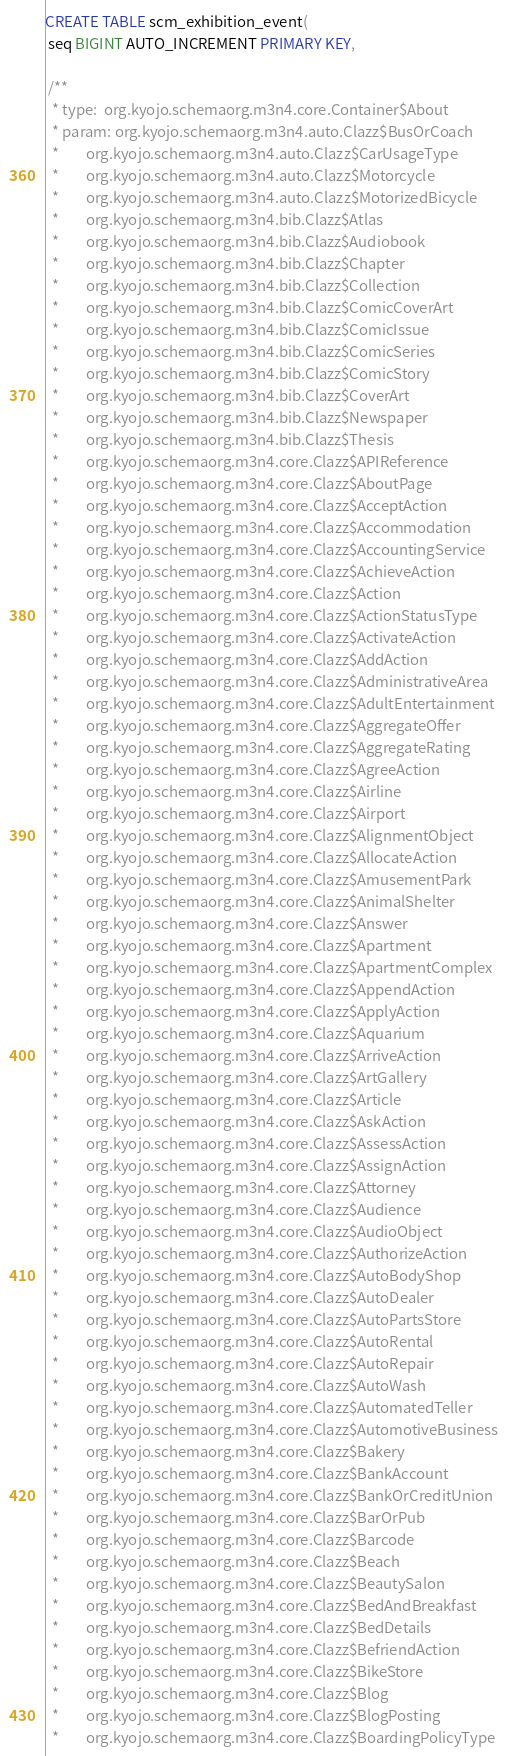<code> <loc_0><loc_0><loc_500><loc_500><_SQL_>CREATE TABLE scm_exhibition_event(
 seq BIGINT AUTO_INCREMENT PRIMARY KEY,

 /**
  * type:  org.kyojo.schemaorg.m3n4.core.Container$About
  * param: org.kyojo.schemaorg.m3n4.auto.Clazz$BusOrCoach
  *        org.kyojo.schemaorg.m3n4.auto.Clazz$CarUsageType
  *        org.kyojo.schemaorg.m3n4.auto.Clazz$Motorcycle
  *        org.kyojo.schemaorg.m3n4.auto.Clazz$MotorizedBicycle
  *        org.kyojo.schemaorg.m3n4.bib.Clazz$Atlas
  *        org.kyojo.schemaorg.m3n4.bib.Clazz$Audiobook
  *        org.kyojo.schemaorg.m3n4.bib.Clazz$Chapter
  *        org.kyojo.schemaorg.m3n4.bib.Clazz$Collection
  *        org.kyojo.schemaorg.m3n4.bib.Clazz$ComicCoverArt
  *        org.kyojo.schemaorg.m3n4.bib.Clazz$ComicIssue
  *        org.kyojo.schemaorg.m3n4.bib.Clazz$ComicSeries
  *        org.kyojo.schemaorg.m3n4.bib.Clazz$ComicStory
  *        org.kyojo.schemaorg.m3n4.bib.Clazz$CoverArt
  *        org.kyojo.schemaorg.m3n4.bib.Clazz$Newspaper
  *        org.kyojo.schemaorg.m3n4.bib.Clazz$Thesis
  *        org.kyojo.schemaorg.m3n4.core.Clazz$APIReference
  *        org.kyojo.schemaorg.m3n4.core.Clazz$AboutPage
  *        org.kyojo.schemaorg.m3n4.core.Clazz$AcceptAction
  *        org.kyojo.schemaorg.m3n4.core.Clazz$Accommodation
  *        org.kyojo.schemaorg.m3n4.core.Clazz$AccountingService
  *        org.kyojo.schemaorg.m3n4.core.Clazz$AchieveAction
  *        org.kyojo.schemaorg.m3n4.core.Clazz$Action
  *        org.kyojo.schemaorg.m3n4.core.Clazz$ActionStatusType
  *        org.kyojo.schemaorg.m3n4.core.Clazz$ActivateAction
  *        org.kyojo.schemaorg.m3n4.core.Clazz$AddAction
  *        org.kyojo.schemaorg.m3n4.core.Clazz$AdministrativeArea
  *        org.kyojo.schemaorg.m3n4.core.Clazz$AdultEntertainment
  *        org.kyojo.schemaorg.m3n4.core.Clazz$AggregateOffer
  *        org.kyojo.schemaorg.m3n4.core.Clazz$AggregateRating
  *        org.kyojo.schemaorg.m3n4.core.Clazz$AgreeAction
  *        org.kyojo.schemaorg.m3n4.core.Clazz$Airline
  *        org.kyojo.schemaorg.m3n4.core.Clazz$Airport
  *        org.kyojo.schemaorg.m3n4.core.Clazz$AlignmentObject
  *        org.kyojo.schemaorg.m3n4.core.Clazz$AllocateAction
  *        org.kyojo.schemaorg.m3n4.core.Clazz$AmusementPark
  *        org.kyojo.schemaorg.m3n4.core.Clazz$AnimalShelter
  *        org.kyojo.schemaorg.m3n4.core.Clazz$Answer
  *        org.kyojo.schemaorg.m3n4.core.Clazz$Apartment
  *        org.kyojo.schemaorg.m3n4.core.Clazz$ApartmentComplex
  *        org.kyojo.schemaorg.m3n4.core.Clazz$AppendAction
  *        org.kyojo.schemaorg.m3n4.core.Clazz$ApplyAction
  *        org.kyojo.schemaorg.m3n4.core.Clazz$Aquarium
  *        org.kyojo.schemaorg.m3n4.core.Clazz$ArriveAction
  *        org.kyojo.schemaorg.m3n4.core.Clazz$ArtGallery
  *        org.kyojo.schemaorg.m3n4.core.Clazz$Article
  *        org.kyojo.schemaorg.m3n4.core.Clazz$AskAction
  *        org.kyojo.schemaorg.m3n4.core.Clazz$AssessAction
  *        org.kyojo.schemaorg.m3n4.core.Clazz$AssignAction
  *        org.kyojo.schemaorg.m3n4.core.Clazz$Attorney
  *        org.kyojo.schemaorg.m3n4.core.Clazz$Audience
  *        org.kyojo.schemaorg.m3n4.core.Clazz$AudioObject
  *        org.kyojo.schemaorg.m3n4.core.Clazz$AuthorizeAction
  *        org.kyojo.schemaorg.m3n4.core.Clazz$AutoBodyShop
  *        org.kyojo.schemaorg.m3n4.core.Clazz$AutoDealer
  *        org.kyojo.schemaorg.m3n4.core.Clazz$AutoPartsStore
  *        org.kyojo.schemaorg.m3n4.core.Clazz$AutoRental
  *        org.kyojo.schemaorg.m3n4.core.Clazz$AutoRepair
  *        org.kyojo.schemaorg.m3n4.core.Clazz$AutoWash
  *        org.kyojo.schemaorg.m3n4.core.Clazz$AutomatedTeller
  *        org.kyojo.schemaorg.m3n4.core.Clazz$AutomotiveBusiness
  *        org.kyojo.schemaorg.m3n4.core.Clazz$Bakery
  *        org.kyojo.schemaorg.m3n4.core.Clazz$BankAccount
  *        org.kyojo.schemaorg.m3n4.core.Clazz$BankOrCreditUnion
  *        org.kyojo.schemaorg.m3n4.core.Clazz$BarOrPub
  *        org.kyojo.schemaorg.m3n4.core.Clazz$Barcode
  *        org.kyojo.schemaorg.m3n4.core.Clazz$Beach
  *        org.kyojo.schemaorg.m3n4.core.Clazz$BeautySalon
  *        org.kyojo.schemaorg.m3n4.core.Clazz$BedAndBreakfast
  *        org.kyojo.schemaorg.m3n4.core.Clazz$BedDetails
  *        org.kyojo.schemaorg.m3n4.core.Clazz$BefriendAction
  *        org.kyojo.schemaorg.m3n4.core.Clazz$BikeStore
  *        org.kyojo.schemaorg.m3n4.core.Clazz$Blog
  *        org.kyojo.schemaorg.m3n4.core.Clazz$BlogPosting
  *        org.kyojo.schemaorg.m3n4.core.Clazz$BoardingPolicyType</code> 